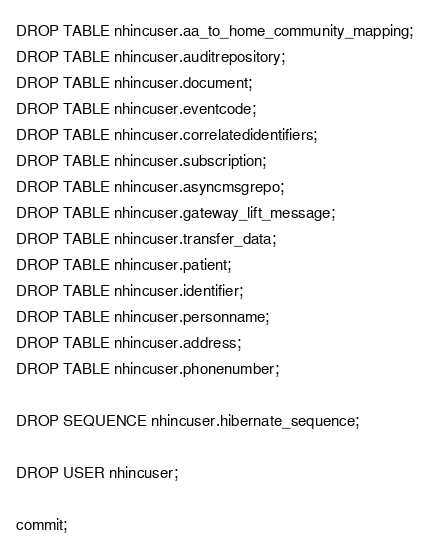<code> <loc_0><loc_0><loc_500><loc_500><_SQL_>
DROP TABLE nhincuser.aa_to_home_community_mapping;
DROP TABLE nhincuser.auditrepository;
DROP TABLE nhincuser.document;
DROP TABLE nhincuser.eventcode;
DROP TABLE nhincuser.correlatedidentifiers;
DROP TABLE nhincuser.subscription;
DROP TABLE nhincuser.asyncmsgrepo;
DROP TABLE nhincuser.gateway_lift_message;
DROP TABLE nhincuser.transfer_data;
DROP TABLE nhincuser.patient;
DROP TABLE nhincuser.identifier;
DROP TABLE nhincuser.personname;
DROP TABLE nhincuser.address;
DROP TABLE nhincuser.phonenumber;

DROP SEQUENCE nhincuser.hibernate_sequence;

DROP USER nhincuser;

commit;
</code> 